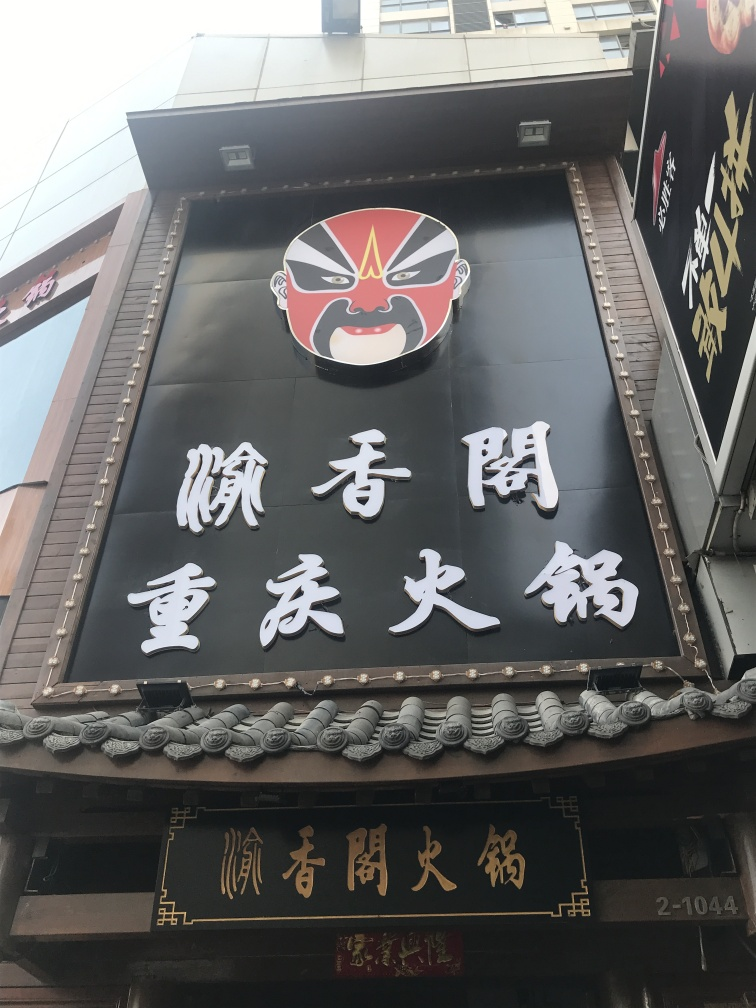Are the texts on the wall clear and visible?
A. Yes
B. No
Answer with the option's letter from the given choices directly.
 A. 